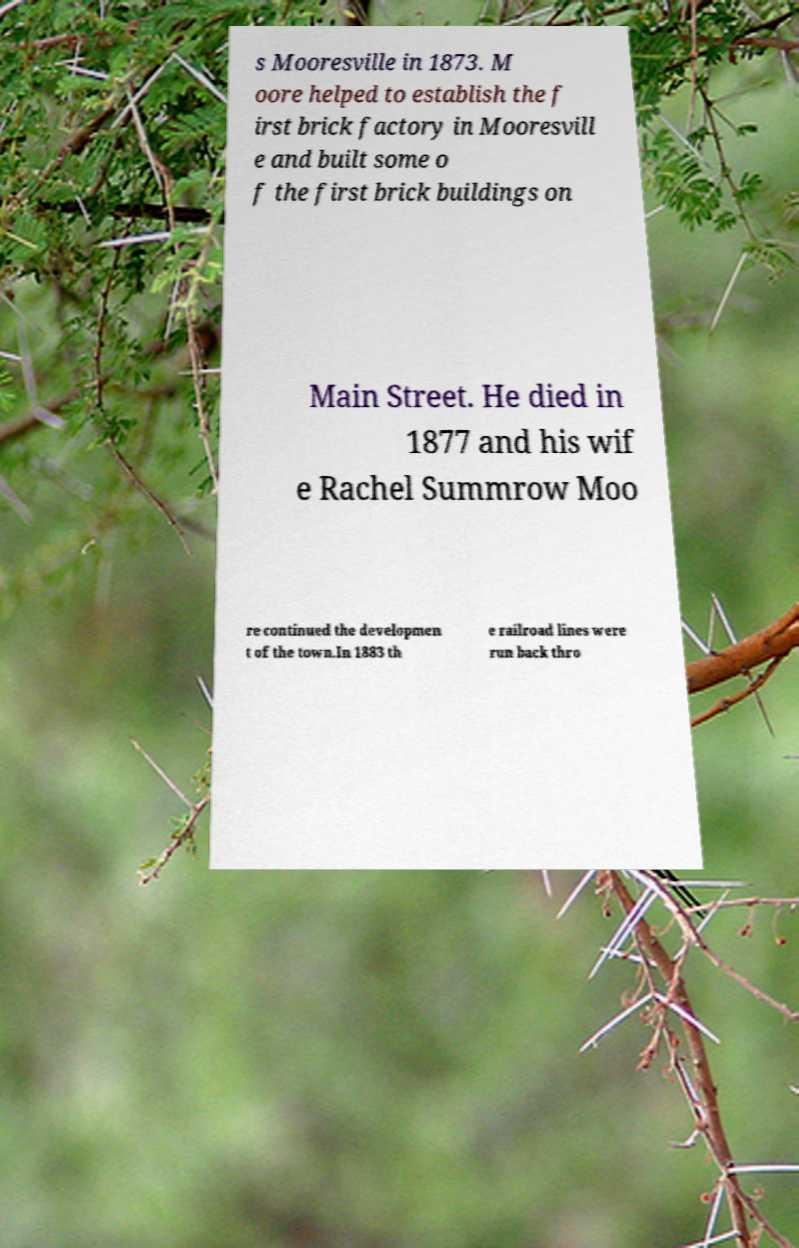Can you read and provide the text displayed in the image?This photo seems to have some interesting text. Can you extract and type it out for me? s Mooresville in 1873. M oore helped to establish the f irst brick factory in Mooresvill e and built some o f the first brick buildings on Main Street. He died in 1877 and his wif e Rachel Summrow Moo re continued the developmen t of the town.In 1883 th e railroad lines were run back thro 